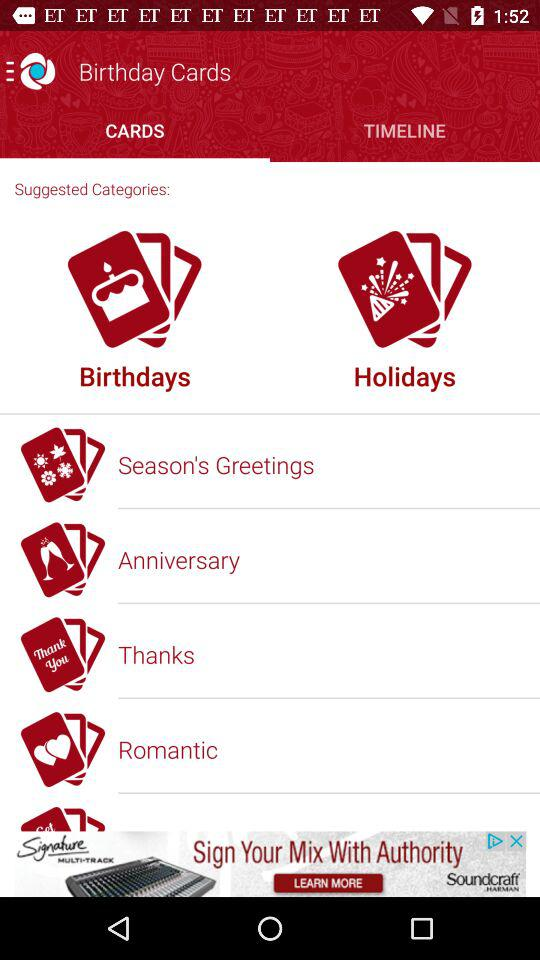What is the name of the application? The name of the application is "Birthday Cards". 